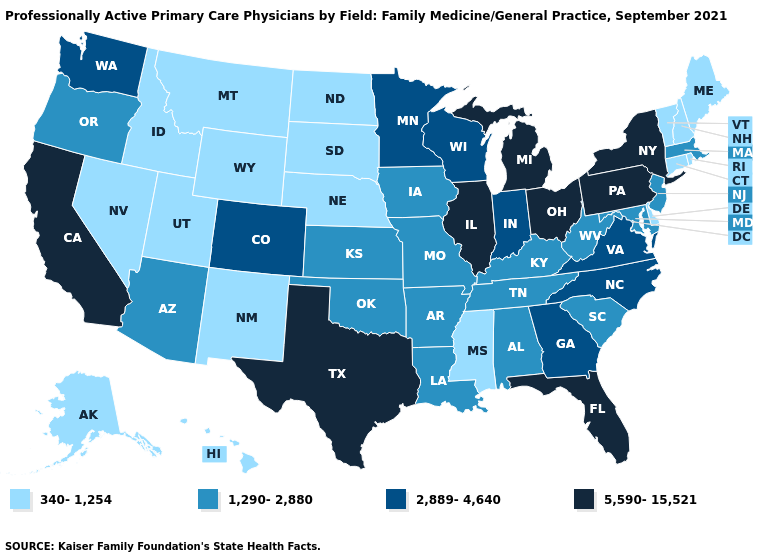What is the value of Oklahoma?
Write a very short answer. 1,290-2,880. Name the states that have a value in the range 1,290-2,880?
Keep it brief. Alabama, Arizona, Arkansas, Iowa, Kansas, Kentucky, Louisiana, Maryland, Massachusetts, Missouri, New Jersey, Oklahoma, Oregon, South Carolina, Tennessee, West Virginia. How many symbols are there in the legend?
Give a very brief answer. 4. What is the highest value in the West ?
Quick response, please. 5,590-15,521. Which states hav the highest value in the Northeast?
Give a very brief answer. New York, Pennsylvania. What is the value of Missouri?
Short answer required. 1,290-2,880. What is the value of Arizona?
Keep it brief. 1,290-2,880. What is the value of Hawaii?
Keep it brief. 340-1,254. Name the states that have a value in the range 340-1,254?
Write a very short answer. Alaska, Connecticut, Delaware, Hawaii, Idaho, Maine, Mississippi, Montana, Nebraska, Nevada, New Hampshire, New Mexico, North Dakota, Rhode Island, South Dakota, Utah, Vermont, Wyoming. Among the states that border Nevada , does Arizona have the lowest value?
Answer briefly. No. Does Ohio have the lowest value in the USA?
Be succinct. No. Does the first symbol in the legend represent the smallest category?
Give a very brief answer. Yes. Which states have the highest value in the USA?
Give a very brief answer. California, Florida, Illinois, Michigan, New York, Ohio, Pennsylvania, Texas. What is the lowest value in the USA?
Keep it brief. 340-1,254. 